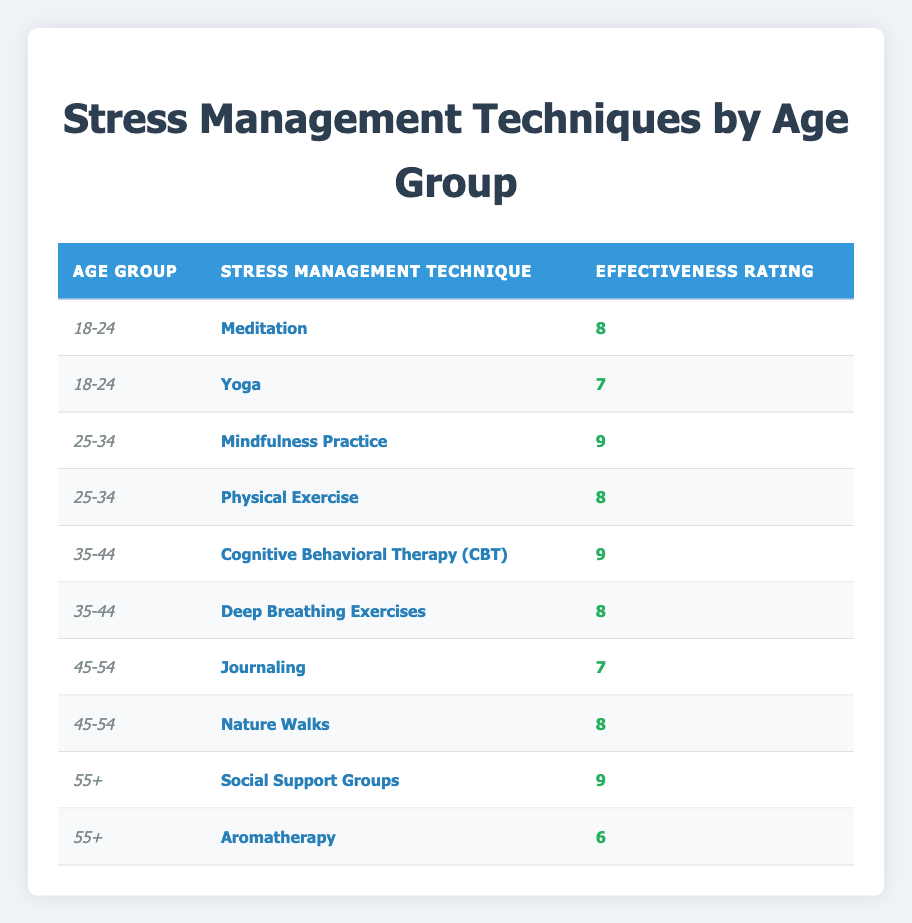What is the effectiveness rating for Meditation in the 18-24 age group? The effectiveness rating for Meditation in the 18-24 age group is listed directly in the table, which shows a rating of 8 next to the technique.
Answer: 8 Which age group reported the highest effectiveness rating for stress management techniques? The highest effectiveness rating in the table is 9, which appears in two instances: for Mindfulness Practice (25-34 age group) and Cognitive Behavioral Therapy (CBT) (35-44 age group). Both are the highest ratings observed across all age groups.
Answer: 25-34 and 35-44 age groups What is the average effectiveness rating for stress management techniques in the 45-54 age group? For the 45-54 age group, the effectiveness ratings are 7 (for Journaling) and 8 (for Nature Walks). Summing them gives 7 + 8 = 15. Since there are two techniques, the average is 15 divided by 2, which equals 7.5.
Answer: 7.5 Is Aromatherapy considered a highly rated technique in the 55+ age group? Aromatherapy has an effectiveness rating of 6, which is lower than the other technique in this age group, Social Support Groups, which has a rating of 9. Therefore, it is not considered highly rated.
Answer: No How many total stress management techniques are mentioned for the age group 35-44? The age group 35-44 has two stress management techniques listed in the table: Cognitive Behavioral Therapy (CBT) and Deep Breathing Exercises. Therefore, the total number of techniques for this group is 2.
Answer: 2 